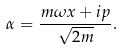<formula> <loc_0><loc_0><loc_500><loc_500>\alpha = \frac { m \omega x + i p } { \sqrt { 2 m } } .</formula> 